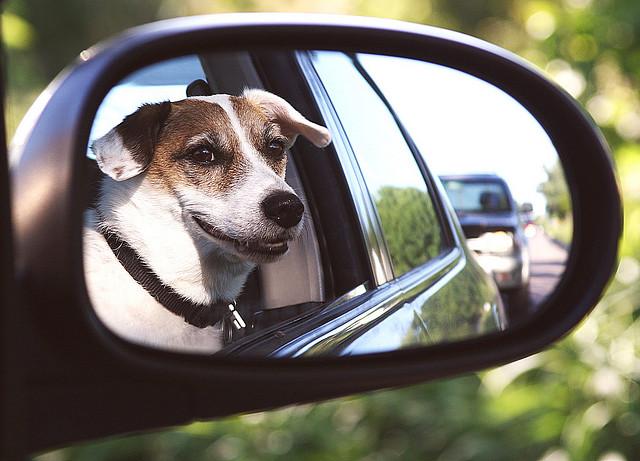What kind of dog is it?
Write a very short answer. Terrier. Is the dog wearing a collar?
Short answer required. Yes. What kind of mirror is the dog looking in?
Write a very short answer. Car. Is the dog driving?
Answer briefly. No. 